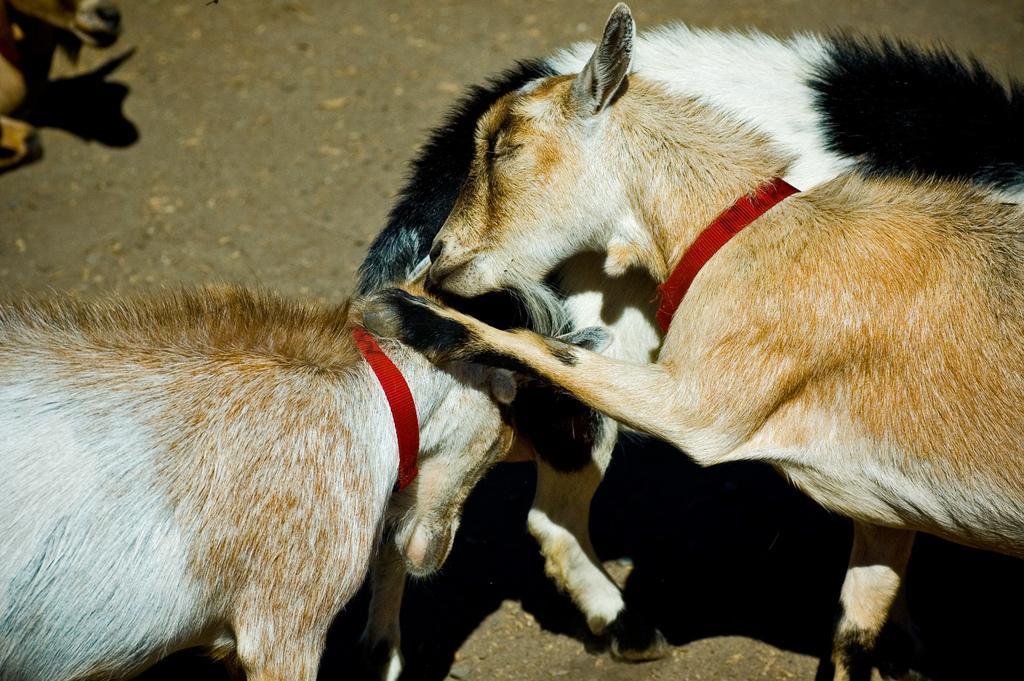Please provide a concise description of this image. This image consists of goats. At the bottom, there is a road. And they are tied with red color belts. 